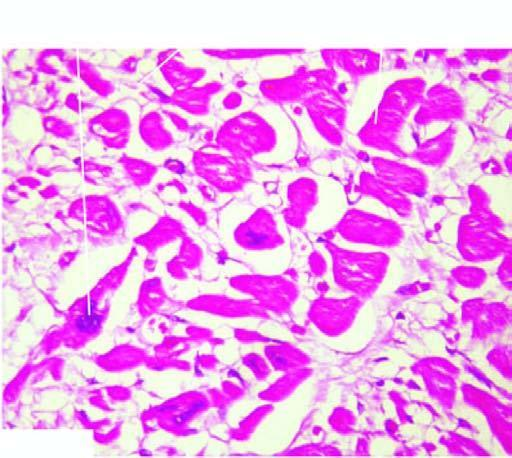what are also enlarged with irregular outlines?
Answer the question using a single word or phrase. Nuclei 